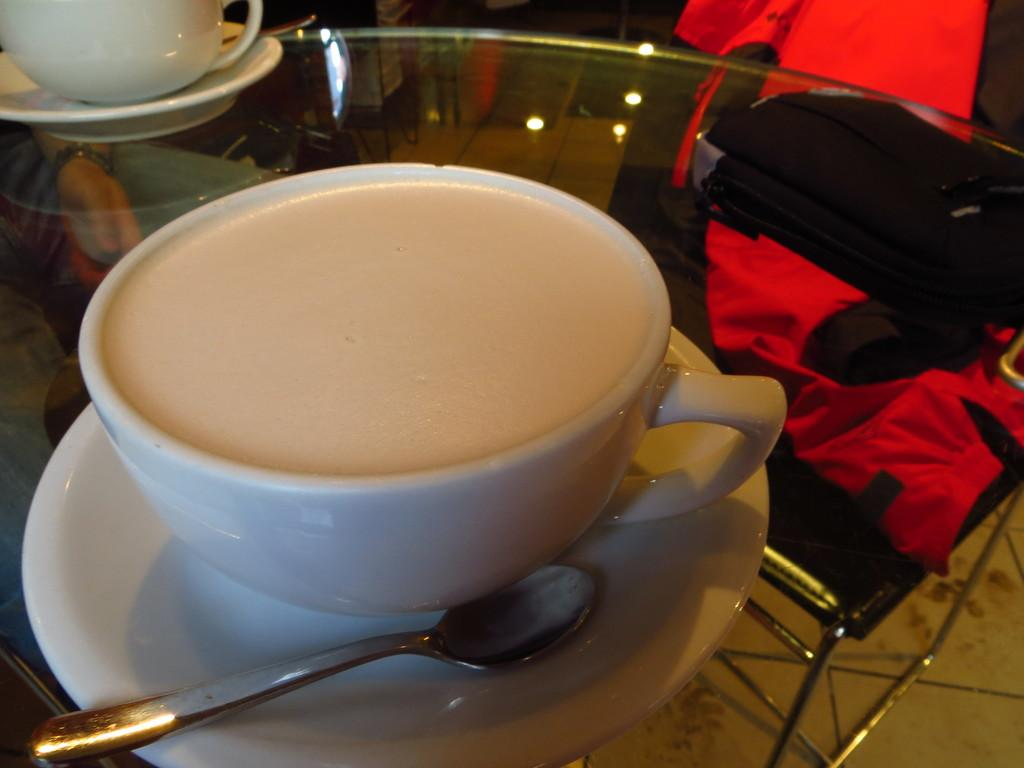What type of table is visible in the image? There is a glass table in the image. What items are placed on the table? There are cups and saucers, a spoon, and a bag on the table. Is there any seating visible in the image? Yes, there is a chair behind the table. What type of stick is used to stir the contents of the bag in the image? There is no stick or stirring activity present in the image. The bag is simply placed on the table alongside other items. 